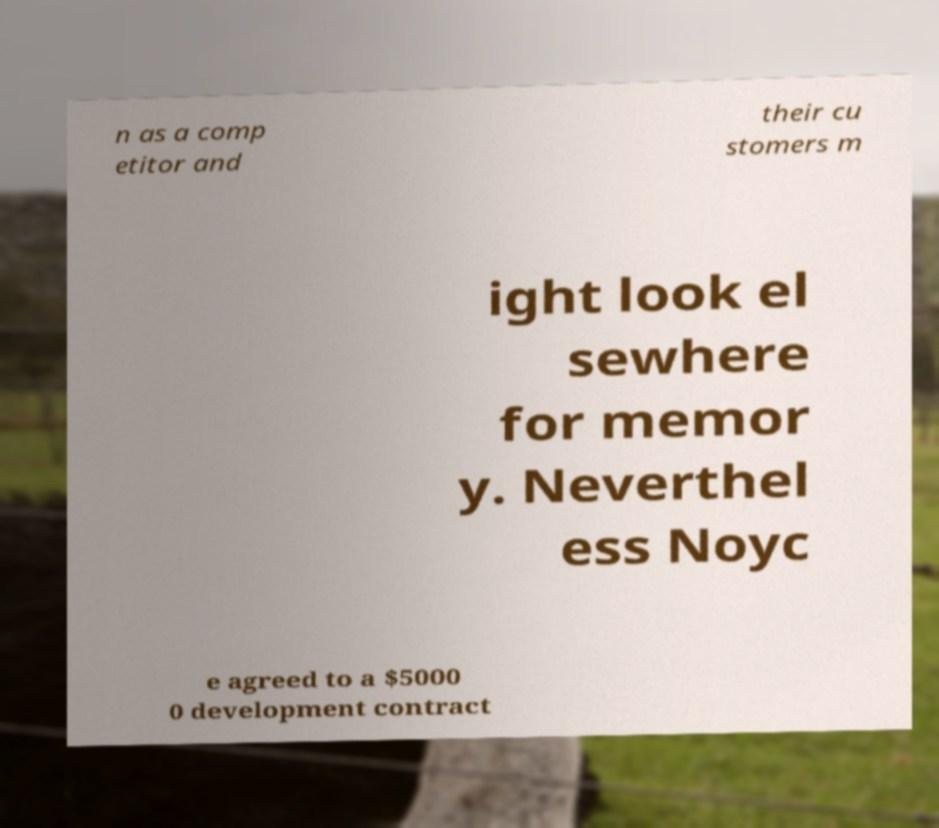Can you read and provide the text displayed in the image?This photo seems to have some interesting text. Can you extract and type it out for me? n as a comp etitor and their cu stomers m ight look el sewhere for memor y. Neverthel ess Noyc e agreed to a $5000 0 development contract 